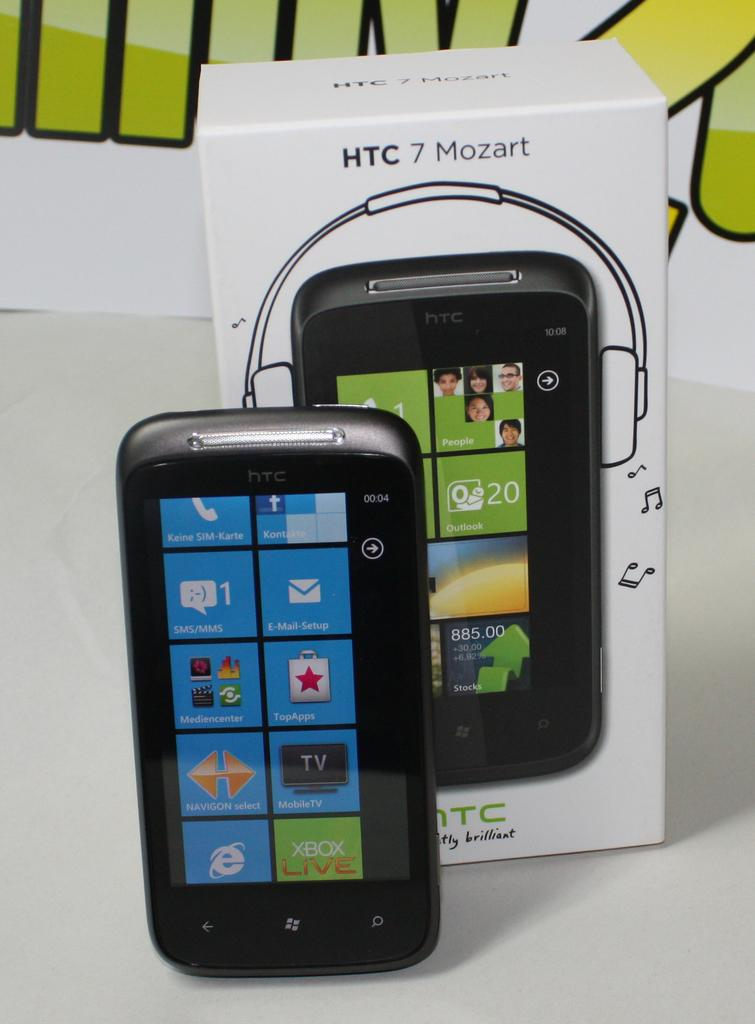<image>
Provide a brief description of the given image. A phone made by HTC called the 7 Mozart. 